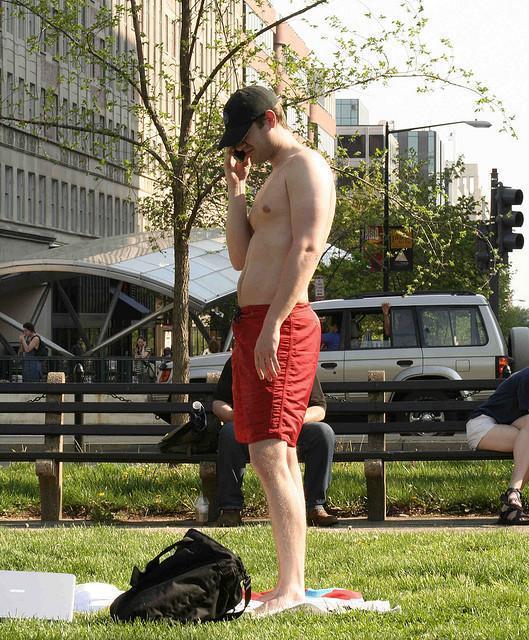How many people are there?
Give a very brief answer. 3. How many benches are visible?
Give a very brief answer. 2. 